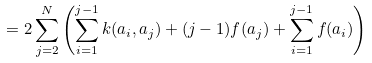Convert formula to latex. <formula><loc_0><loc_0><loc_500><loc_500>= 2 \sum _ { j = 2 } ^ { N } \left ( \sum _ { i = 1 } ^ { j - 1 } k ( a _ { i } , a _ { j } ) + ( j - 1 ) f ( a _ { j } ) + \sum _ { i = 1 } ^ { j - 1 } f ( a _ { i } ) \right ) \,</formula> 